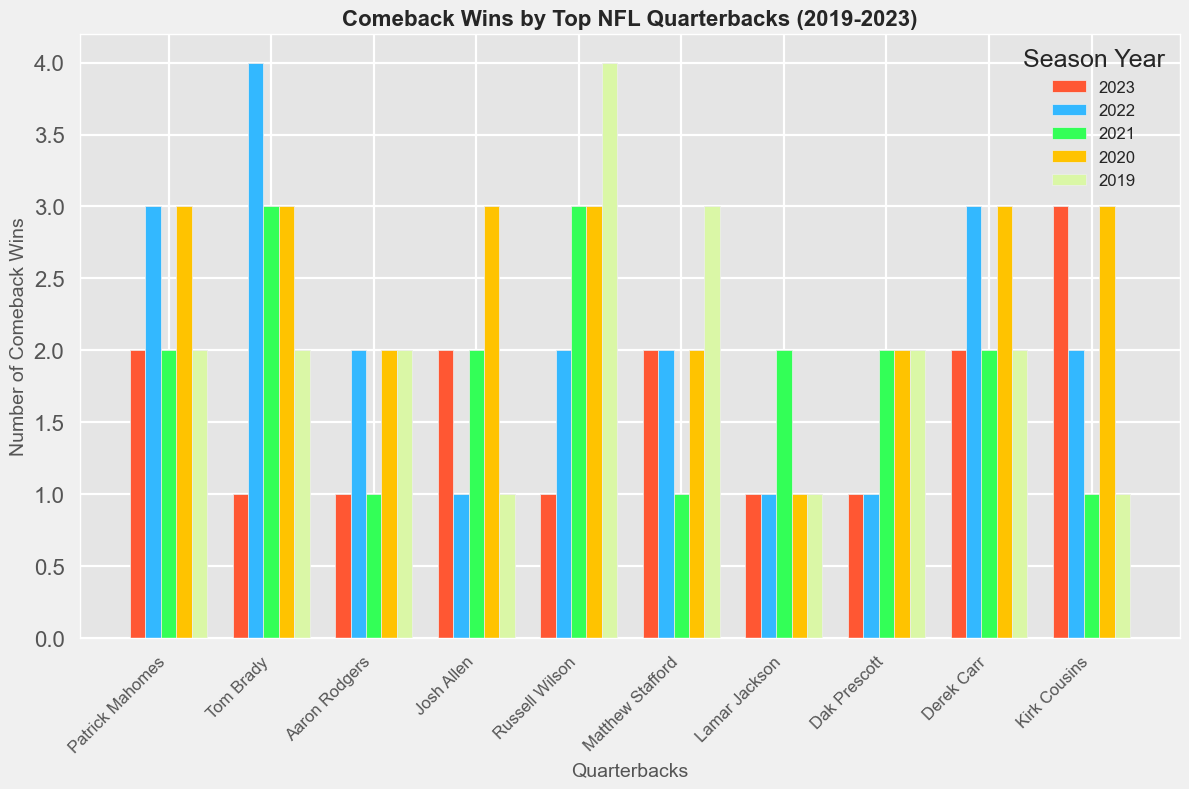What is the total number of comeback wins for Patrick Mahomes across all five years? Sum the number of comeback wins for Patrick Mahomes from 2019 to 2023: 2 (2019) + 3 (2020) + 2 (2021) + 3 (2022) + 2 (2023) = 12
Answer: 12 Which quarterback had the most comeback wins in 2022? Look at the heights of the bars belonging to the year 2022 and find the tallest one. Tom Brady has the tallest bar for 2022 with 4 comeback wins.
Answer: Tom Brady How does the total number of comeback wins for Patrick Mahomes compare to Aaron Rodgers over the five years? Calculate the total for both quarterbacks. Patrick Mahomes: 2+3+2+3+2 = 12; Aaron Rodgers: 2+2+1+2+2 = 8. Patrick Mahomes has more comeback wins.
Answer: Patrick Mahomes has more What is the trend for Patrick Mahomes' comeback wins from 2019 to 2023? Observe the height of the bars for Patrick Mahomes from 2019 to 2023. The wins remain relatively consistent with minor fluctuations: 2, 3, 2, 3, 2.
Answer: Relatively consistent Compare the total number of comeback wins in 2021 for Patrick Mahomes and Derek Carr. Look at the heights of the bars for 2021 for both quarterbacks. Patrick Mahomes has 2 comeback wins, and Derek Carr also has 2.
Answer: They are equal Which year shows the highest number of comeback wins for Matthew Stafford, and how many? Identify the tallest bar for Matthew Stafford: 2019 has 3 wins.
Answer: 2019, 3 wins Who has the least number of comeback wins in 2023, and how many? Look at the bars for 2023 and find the shortest one. Tom Brady, Aaron Rodgers, Russell Wilson, Lamar Jackson, and Dak Prescott all have 1 comeback win each.
Answer: Multiple quarterbacks, 1 win Compare the number of comeback wins between Josh Allen and Russell Wilson in 2020. Check the heights of the bars for Josh Allen and Russell Wilson in 2020. Both have 3 wins in 2020.
Answer: They are equal What is the average number of comeback wins for Kirk Cousins from 2019 to 2023? Calculate the average: (1+3+1+2+3)/5 = 2.
Answer: 2 Who had more comeback wins in 2019, Lamar Jackson or Dak Prescott? Compare the 2019 bars for both quarterbacks. Lamar Jackson has 1, while Dak Prescott has 2.
Answer: Dak Prescott 